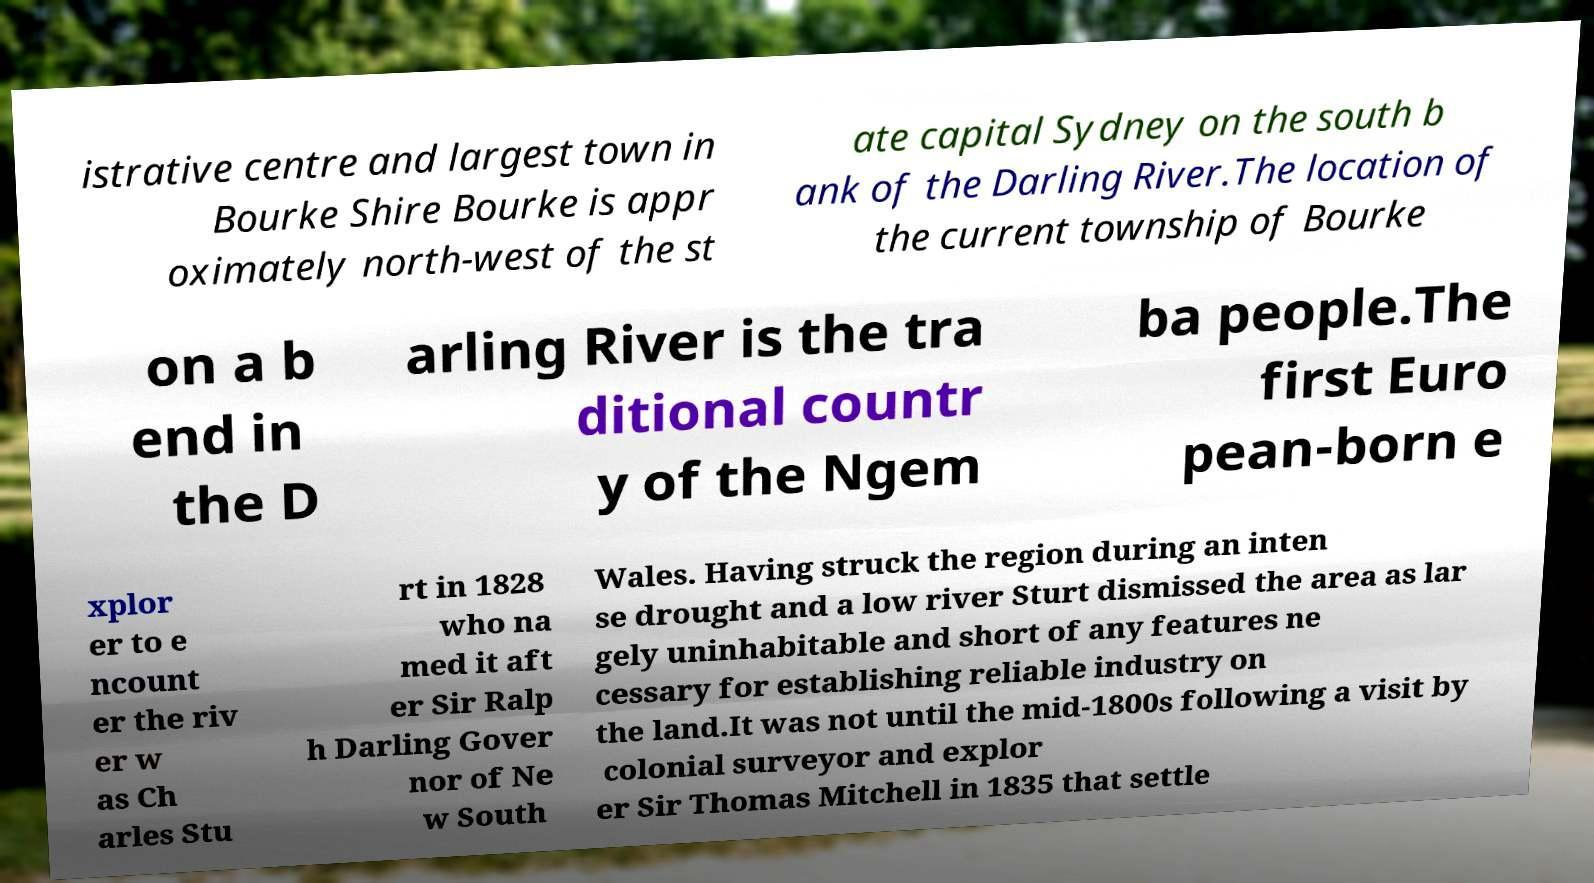Please read and relay the text visible in this image. What does it say? istrative centre and largest town in Bourke Shire Bourke is appr oximately north-west of the st ate capital Sydney on the south b ank of the Darling River.The location of the current township of Bourke on a b end in the D arling River is the tra ditional countr y of the Ngem ba people.The first Euro pean-born e xplor er to e ncount er the riv er w as Ch arles Stu rt in 1828 who na med it aft er Sir Ralp h Darling Gover nor of Ne w South Wales. Having struck the region during an inten se drought and a low river Sturt dismissed the area as lar gely uninhabitable and short of any features ne cessary for establishing reliable industry on the land.It was not until the mid-1800s following a visit by colonial surveyor and explor er Sir Thomas Mitchell in 1835 that settle 